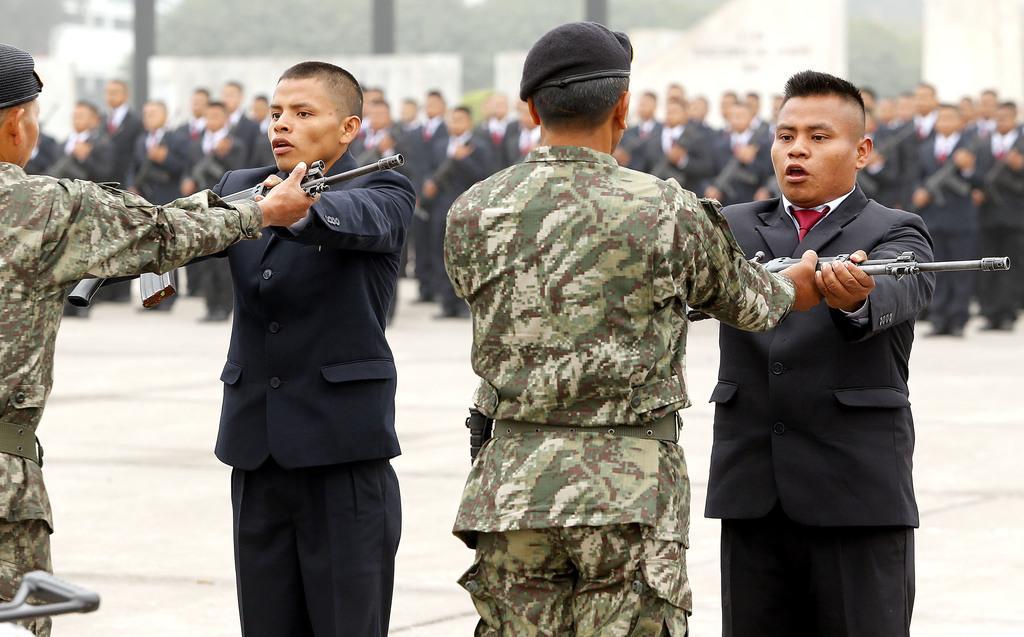Describe this image in one or two sentences. In this picture there are people in the center of the image, by holding pistols in their hands and there are other people those who are standing in series in the background area of the image. 